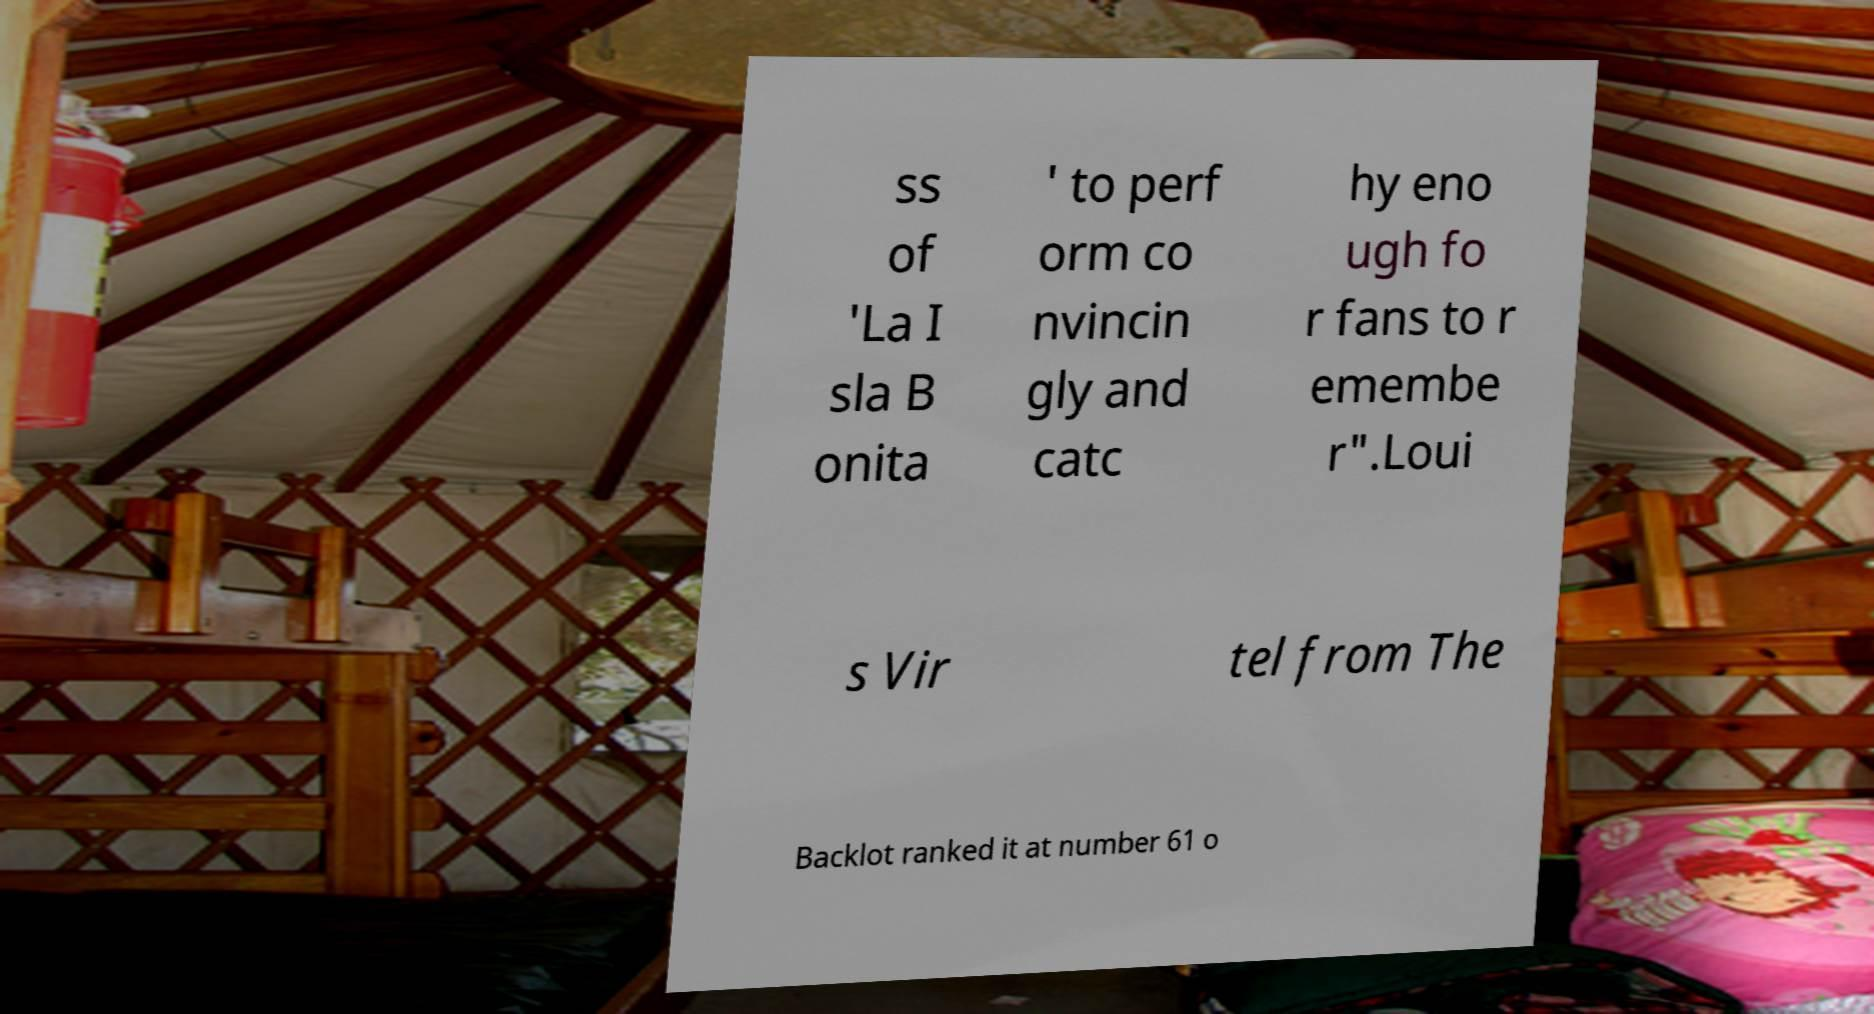Could you extract and type out the text from this image? ss of 'La I sla B onita ' to perf orm co nvincin gly and catc hy eno ugh fo r fans to r emembe r".Loui s Vir tel from The Backlot ranked it at number 61 o 